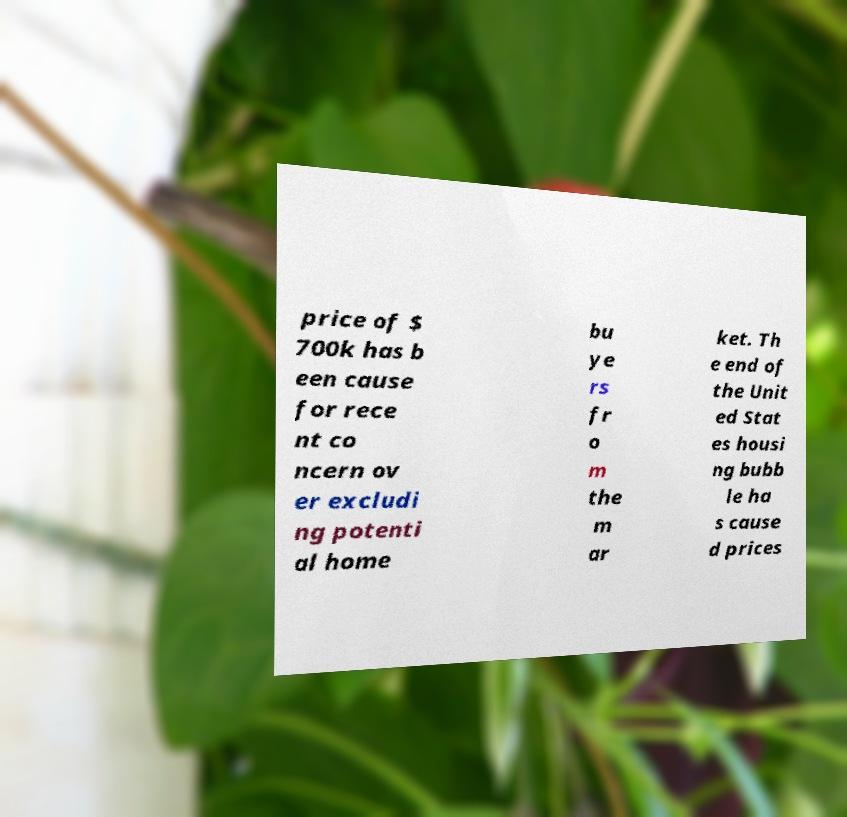Can you read and provide the text displayed in the image?This photo seems to have some interesting text. Can you extract and type it out for me? price of $ 700k has b een cause for rece nt co ncern ov er excludi ng potenti al home bu ye rs fr o m the m ar ket. Th e end of the Unit ed Stat es housi ng bubb le ha s cause d prices 